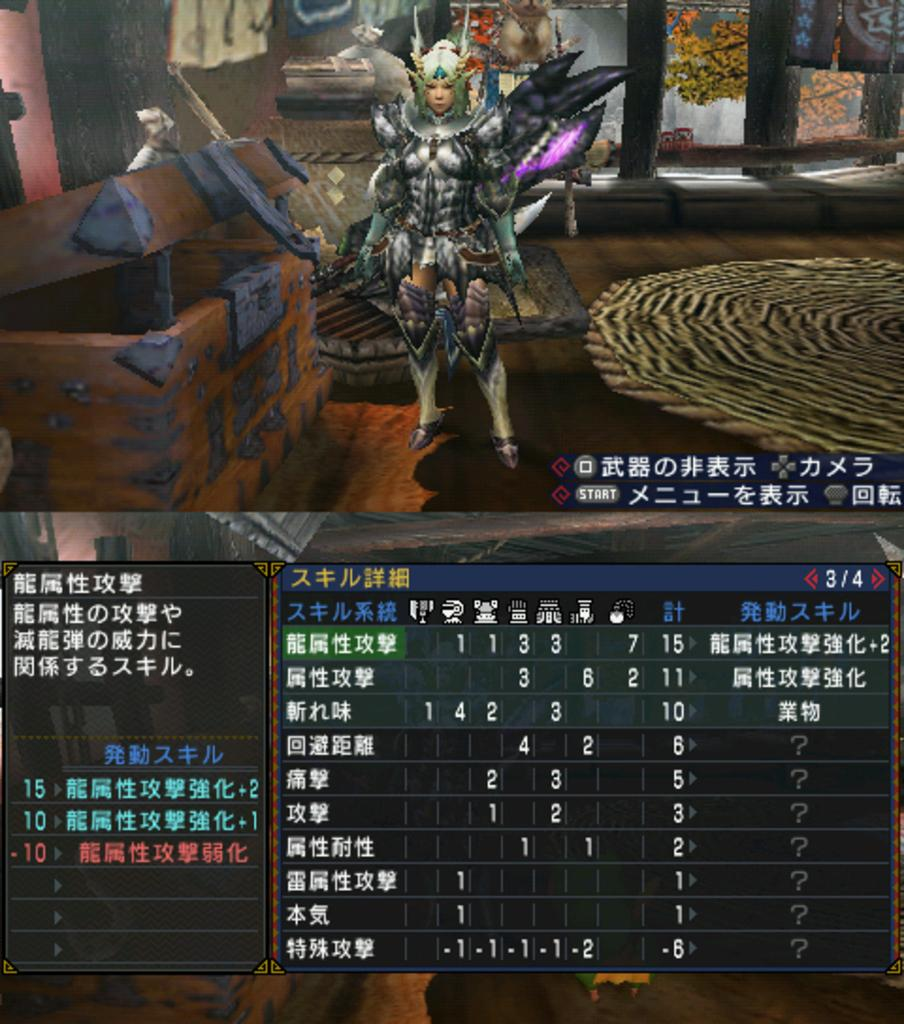<image>
Summarize the visual content of the image. A video game scene is displayed with a scoreboard that has "start" at the top. 